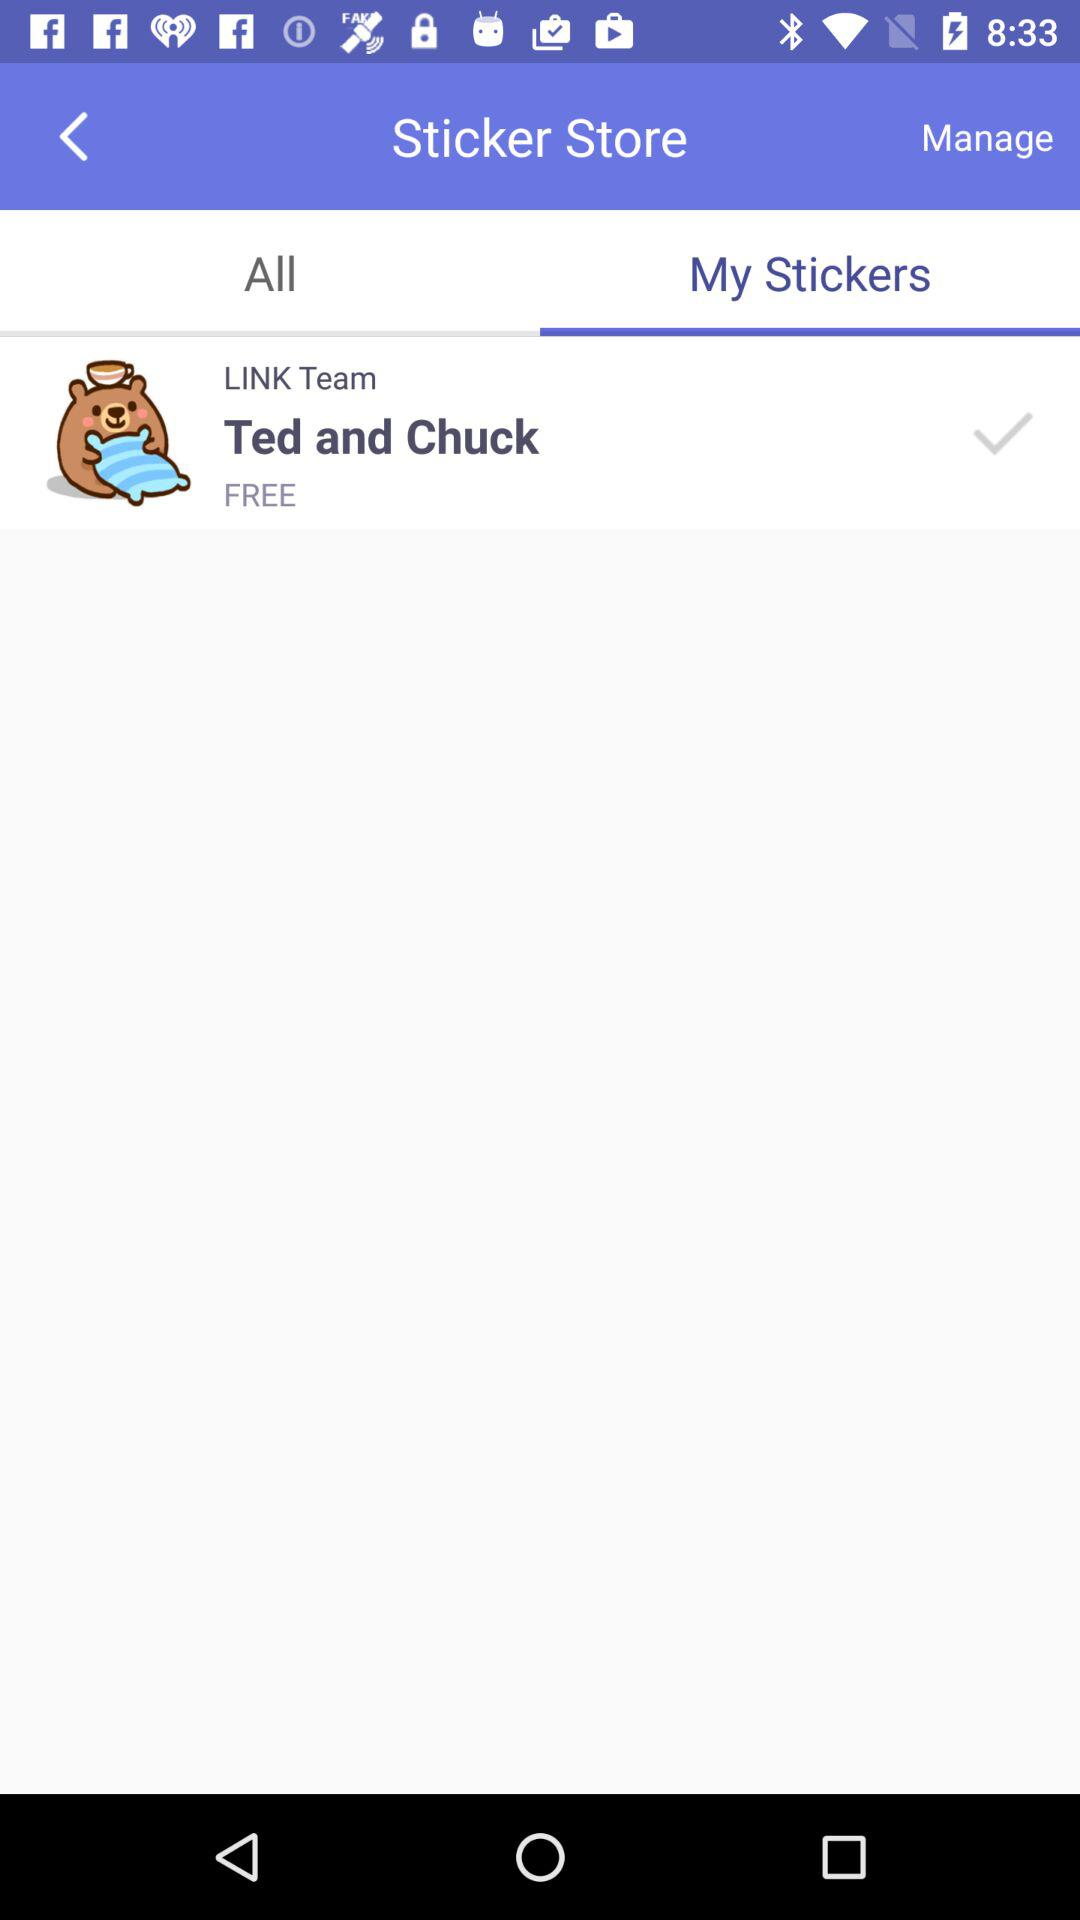What option is selected for the sticker store? The selected option is "My Stickers". 